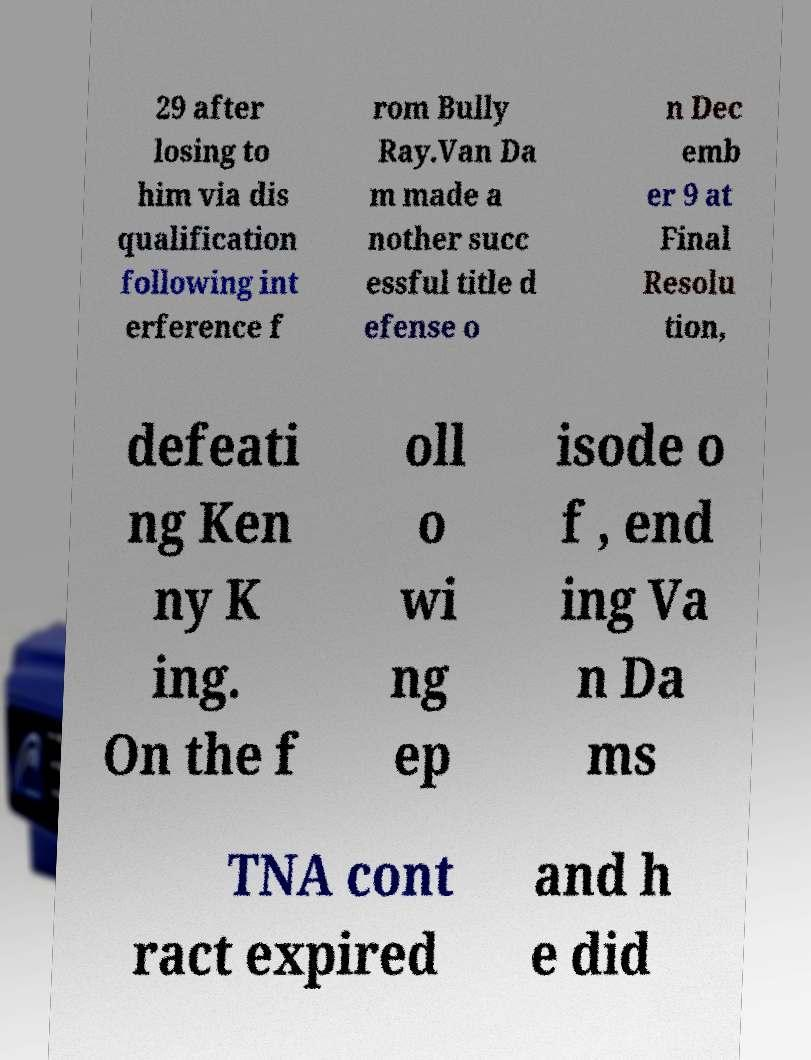Could you assist in decoding the text presented in this image and type it out clearly? 29 after losing to him via dis qualification following int erference f rom Bully Ray.Van Da m made a nother succ essful title d efense o n Dec emb er 9 at Final Resolu tion, defeati ng Ken ny K ing. On the f oll o wi ng ep isode o f , end ing Va n Da ms TNA cont ract expired and h e did 